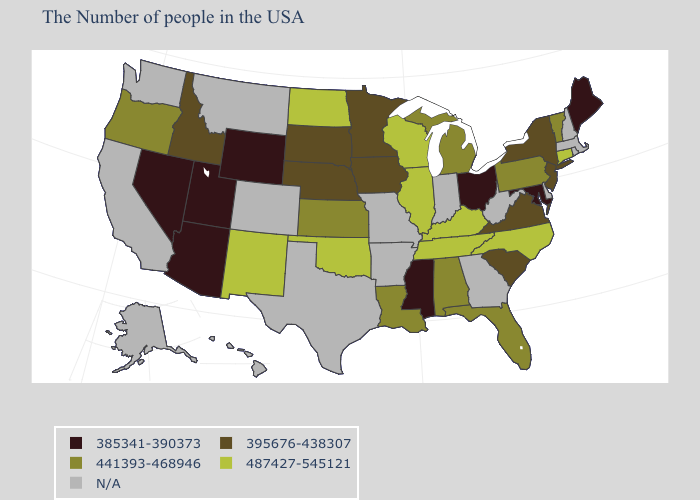How many symbols are there in the legend?
Quick response, please. 5. What is the value of Kentucky?
Concise answer only. 487427-545121. Name the states that have a value in the range 487427-545121?
Give a very brief answer. Connecticut, North Carolina, Kentucky, Tennessee, Wisconsin, Illinois, Oklahoma, North Dakota, New Mexico. Which states have the highest value in the USA?
Concise answer only. Connecticut, North Carolina, Kentucky, Tennessee, Wisconsin, Illinois, Oklahoma, North Dakota, New Mexico. Name the states that have a value in the range 395676-438307?
Short answer required. New York, New Jersey, Virginia, South Carolina, Minnesota, Iowa, Nebraska, South Dakota, Idaho. What is the lowest value in the South?
Keep it brief. 385341-390373. What is the lowest value in states that border Colorado?
Concise answer only. 385341-390373. What is the value of Wisconsin?
Answer briefly. 487427-545121. Name the states that have a value in the range 385341-390373?
Write a very short answer. Maine, Maryland, Ohio, Mississippi, Wyoming, Utah, Arizona, Nevada. Among the states that border North Carolina , which have the lowest value?
Give a very brief answer. Virginia, South Carolina. Is the legend a continuous bar?
Write a very short answer. No. Name the states that have a value in the range 395676-438307?
Be succinct. New York, New Jersey, Virginia, South Carolina, Minnesota, Iowa, Nebraska, South Dakota, Idaho. Name the states that have a value in the range N/A?
Concise answer only. Massachusetts, Rhode Island, New Hampshire, Delaware, West Virginia, Georgia, Indiana, Missouri, Arkansas, Texas, Colorado, Montana, California, Washington, Alaska, Hawaii. Among the states that border Nebraska , which have the lowest value?
Short answer required. Wyoming. 